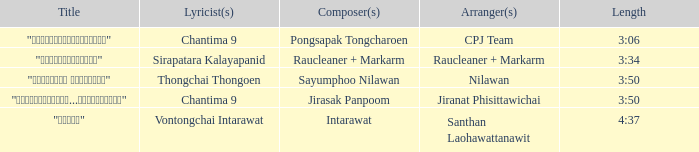Who was the arranger for the song that had a lyricist of Sirapatara Kalayapanid? Raucleaner + Markarm. 